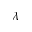Convert formula to latex. <formula><loc_0><loc_0><loc_500><loc_500>\lambda</formula> 